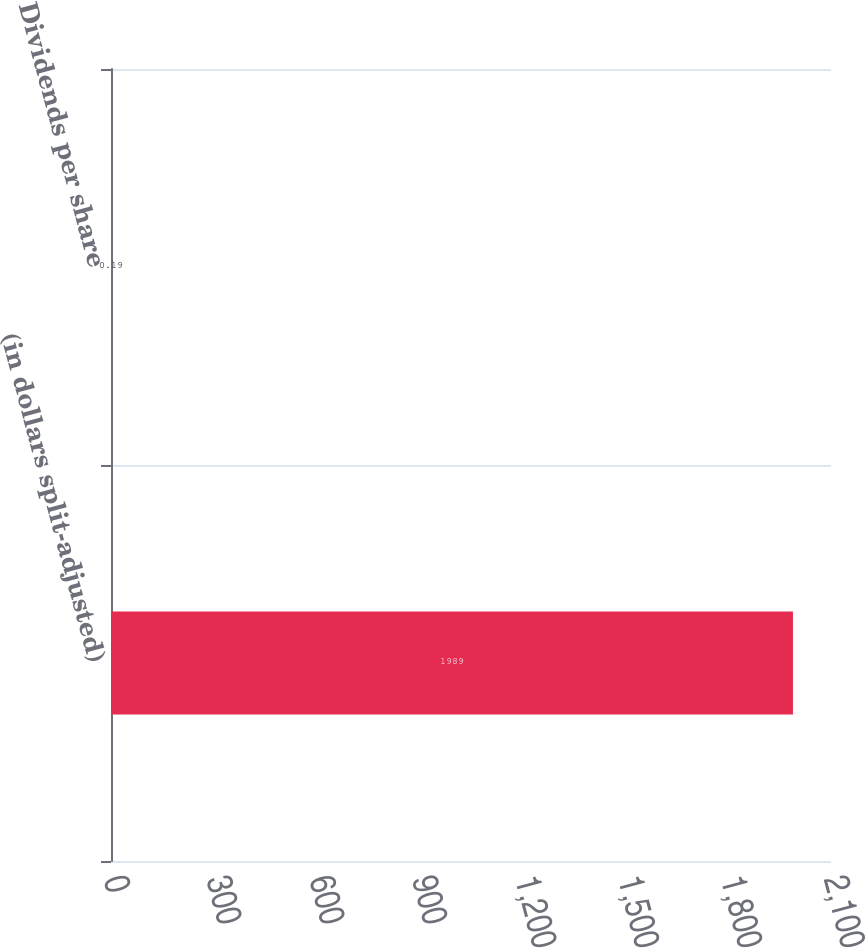<chart> <loc_0><loc_0><loc_500><loc_500><bar_chart><fcel>(in dollars split-adjusted)<fcel>Dividends per share<nl><fcel>1989<fcel>0.19<nl></chart> 